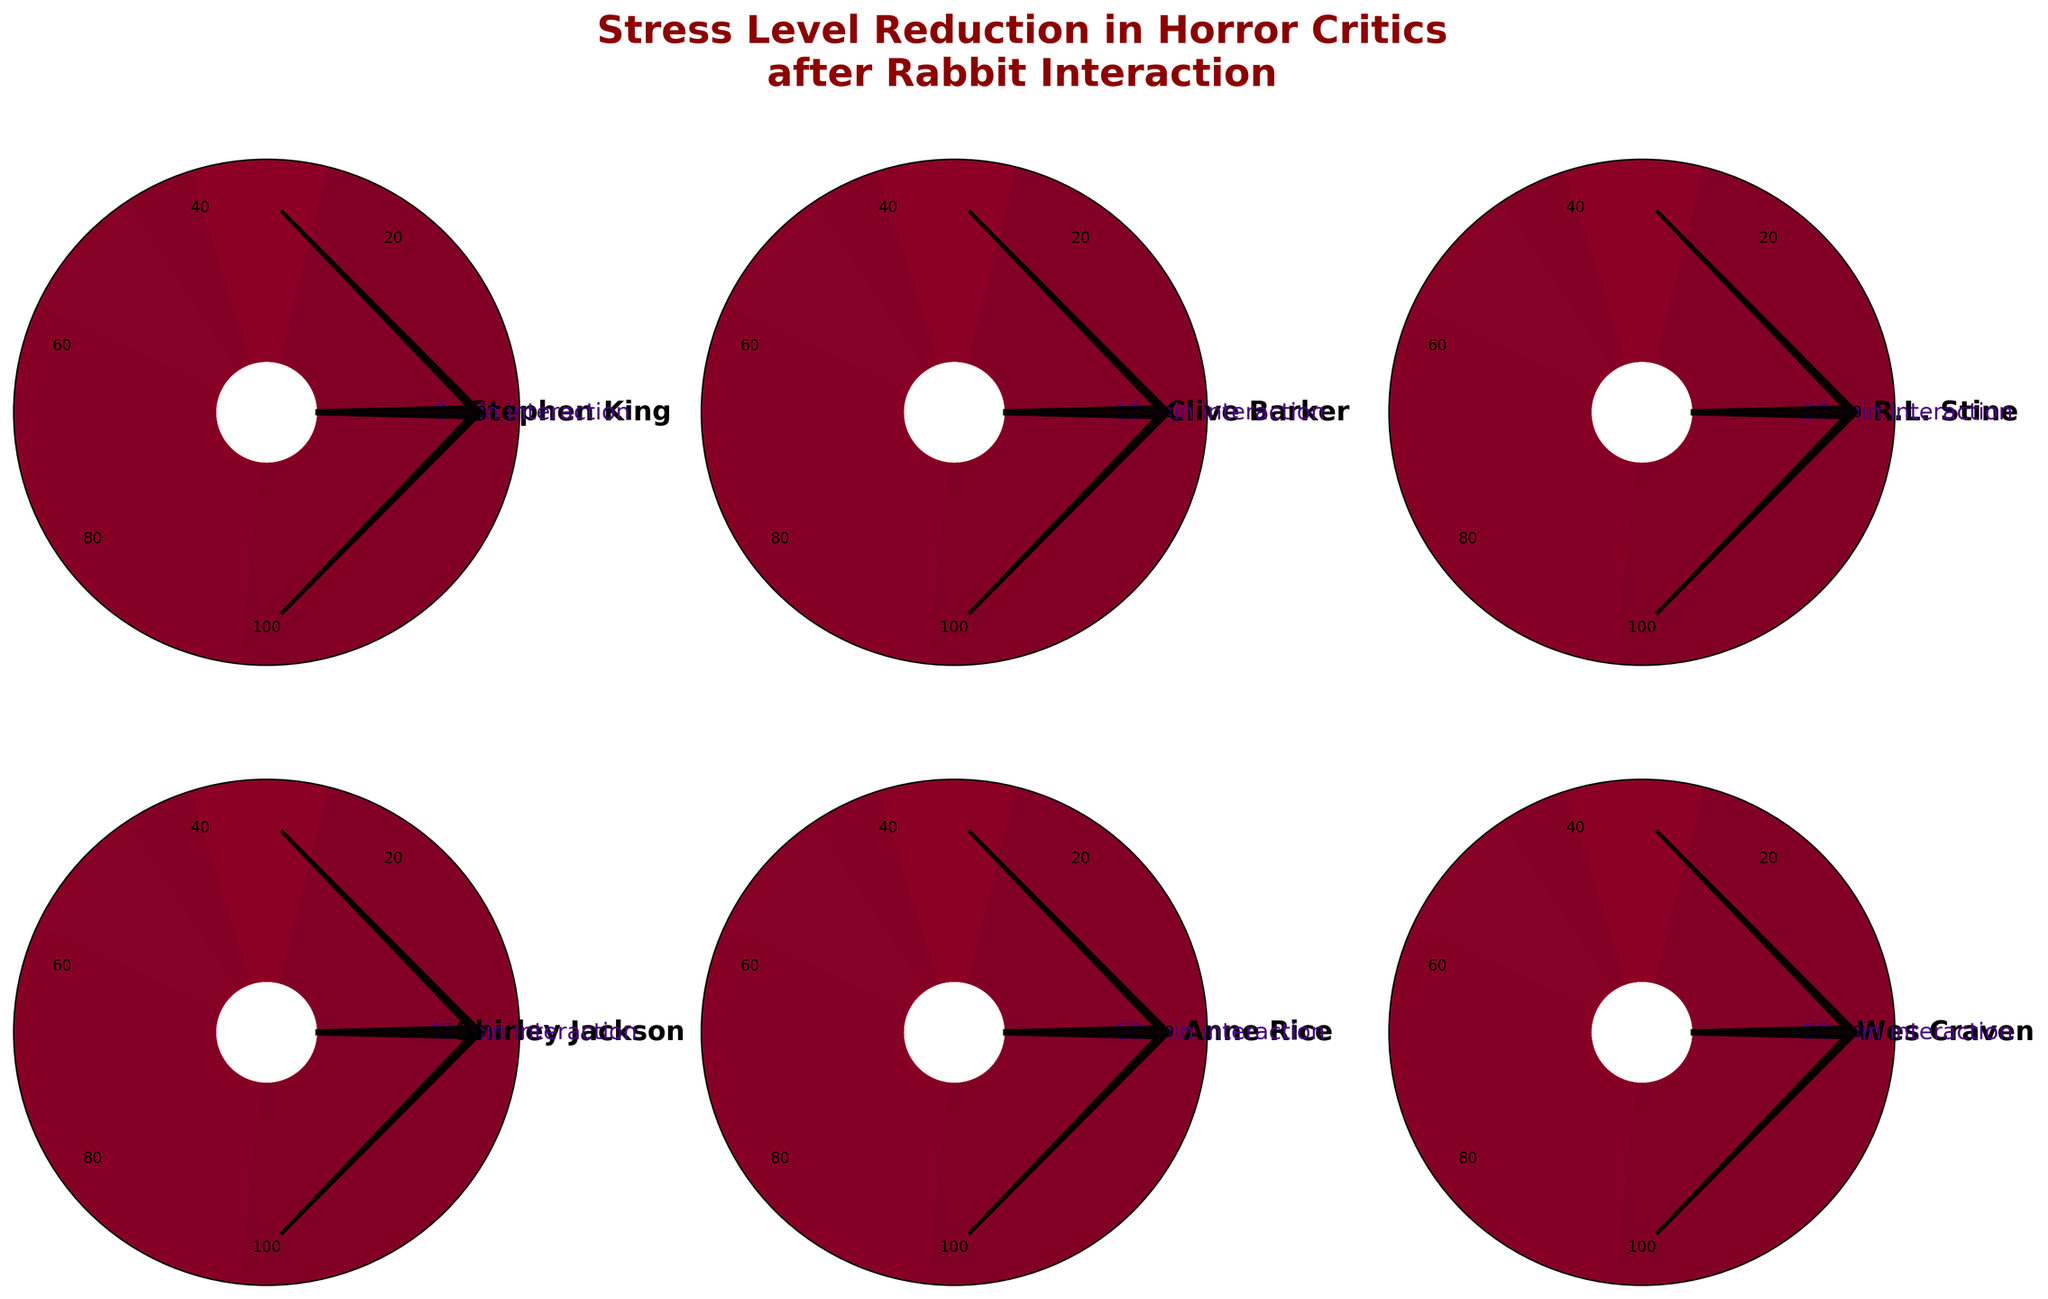What is the title of the figure? The title of the figure appears at the top and states, "Stress Level Reduction in Horror Critics after Rabbit Interaction."
Answer: Stress Level Reduction in Horror Critics after Rabbit Interaction How many critics' stress levels are represented in the figure? There are six plots in total, each representing a different horror critic's stress level.
Answer: Six Which critic had the highest initial stress level? By looking at the stress levels indicated in each plot, Stephen King's plot shows the highest stress level at 85%.
Answer: Stephen King What is the stress level of Anne Rice after rabbit interaction? Checking Anne Rice's plot, her stress level is 20%.
Answer: 20% How much stress did Clive Barker reduce after 15 minutes of rabbit interaction? Clive Barker’s initial stress level is 62%, and after 15 minutes, it’s also shown as 62%. Therefore, there is a reduction of 23 units from Stephen King's 85%.
Answer: 23% Which critic interacted with rabbits for the longest time, and what was their final stress level? By examining the interaction times noted on each plot, Wes Craven interacted the longest for 90 minutes, resulting in a stress level of 10%.
Answer: Wes Craven, 10% What's the difference in stress levels between Stephen King and Shirley Jackson after their respective interaction times? Stephen King's stress level is 85%, and Shirley Jackson's is 30%. The difference is 85% - 30% = 55%.
Answer: 55% Compare the stress levels of R.L. Stine and Anne Rice. Who had a lower level and what were their respective stress levels? R.L. Stine’s stress level is 45% while Anne Rice’s is 20%. Anne Rice had a lower stress level.
Answer: Anne Rice, 45%; 20% Which critic experienced an intermediate reduction in stress levels compared to the rest? Looking at the stress reductions, Shirley Jackson's stress level reduction is intermediate among the critics.
Answer: Shirley Jackson Describe the trend in stress levels of critics in relation to the rabbit interaction time. There is a general trend where longer rabbit interaction times result in lower stress levels.
Answer: Longer interaction times lead to lower stress levels 